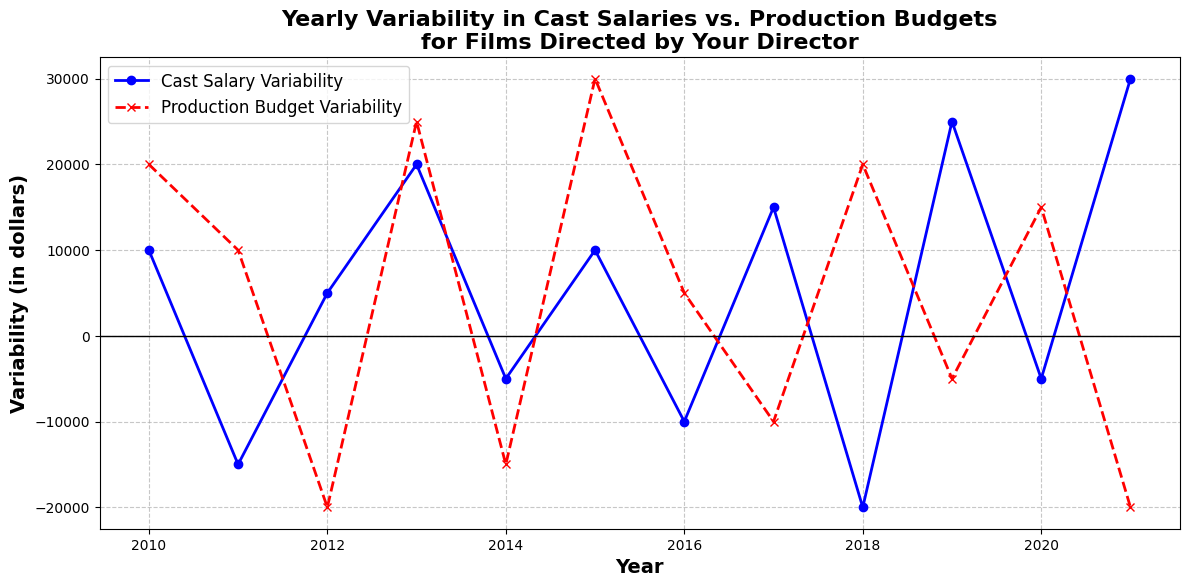What's the year with the highest cast salary variability? The highest cast salary variability is represented by the tallest peak in the blue line. From the chart, the peak is at the year 2021.
Answer: 2021 How many years show negative variability in production budgets? Negative variability in production budgets are indicated by points below the zero line on the red dashed line. By counting, these are in the years 2012, 2014, 2017, 2019, and 2021, which totals to 5 years.
Answer: 5 In which year do cast salary variability and production budget variability both have negative values? Negative values for both metrics would occur below the zero line. The year 2014 shows both lines (blue and red) below zero.
Answer: 2014 Compare the variability between 2019 and 2020. Which year has a higher variability in production budgets? For 2019, the red line is just below zero, indicating a negative value of -5000. For 2020, the red line is well above zero with a positive value of 15000. Thus, 2020 has a higher production budget variability.
Answer: 2020 Did cast salary variability ever reach zero? To find if cast salary variability reached zero, look for a point where the blue line crosses the zero line. The blue line does not cross the zero line in any year.
Answer: No What's the average cast salary variability for the years 2013 and 2014? The values for 2013 and 2014 are 20000 and -5000, respectively. The average is calculated as (20000 + (-5000)) / 2 = 15000 / 2 = 7500.
Answer: 7500 In which year did the production budget variability have a bigger drop compared to the prior year? Comparing year-over-year drops for production budget variability: the biggest drop is from 2011 to 2012 (10000 to -20000). This is a drop of 30000.
Answer: 2012 Is there a year where the cast salary variability increased by more than 20000 from the previous year? Check for increases greater than 20000 between consecutive years. From 2018 to 2019, the increase is (-20000 + 25000) = 45000, which is greater than 20000.
Answer: Yes, 2019 How many times does the cast salary variability cross the zero line? Count the number of times the blue line crosses the zero line. It crosses zero thrice: between 2011-2012, 2016-2017, and 2019-2020.
Answer: 3 